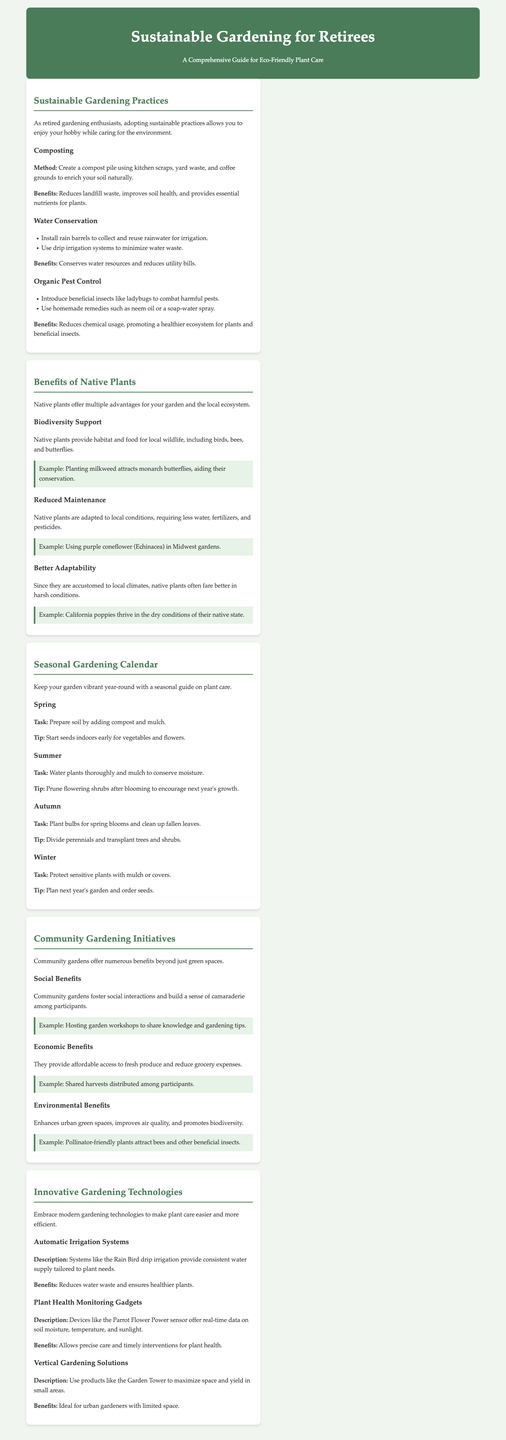What is composting? Composting is the process of creating a pile using kitchen scraps, yard waste, and coffee grounds to enrich soil naturally.
Answer: A method to enrich soil naturally What are two benefits of water conservation? Water conservation benefits include conserving water resources and reducing utility bills.
Answer: Conserves water resources and reduces utility bills What type of plants should you use to attract monarch butterflies? Native plants like milkweed provide habitat and food for local wildlife, including butterflies.
Answer: Milkweed What gardening task is recommended for Autumn? It is recommended to plant bulbs for spring blooms and clean up fallen leaves in Autumn.
Answer: Plant bulbs for spring blooms What is the benefit of community gardens regarding social interactions? Community gardens foster social interactions and build a sense of camaraderie among participants.
Answer: Foster social interactions What does the Garden Tower promote? The Garden Tower promotes vertical gardening solutions to maximize space and yield in small areas.
Answer: Vertical gardening solutions Which technology provides real-time data on soil moisture? The Parrot Flower Power sensor offers real-time data on soil moisture, temperature, and sunlight.
Answer: Parrot Flower Power sensor What is one way to combat harmful pests organically? Introducing beneficial insects like ladybugs is one way to combat harmful pests organically.
Answer: Introduce beneficial insects What is one seasonal task for Spring? The recommended task for Spring is to prepare soil by adding compost and mulch.
Answer: Prepare soil by adding compost and mulch 